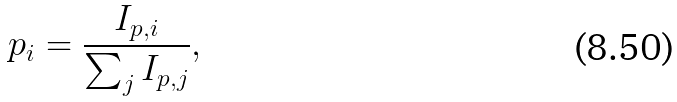<formula> <loc_0><loc_0><loc_500><loc_500>p _ { i } = \frac { I _ { p , i } } { \sum _ { j } I _ { p , j } } ,</formula> 